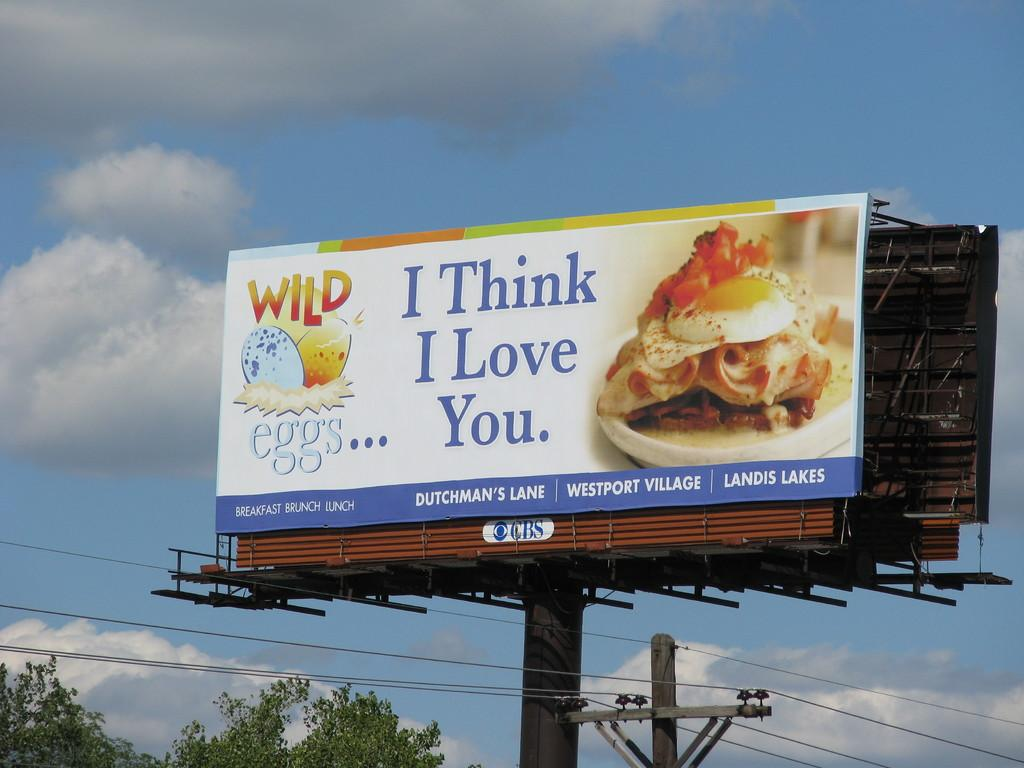<image>
Present a compact description of the photo's key features. A billboard that advertises a company known as Wild Eggs. 